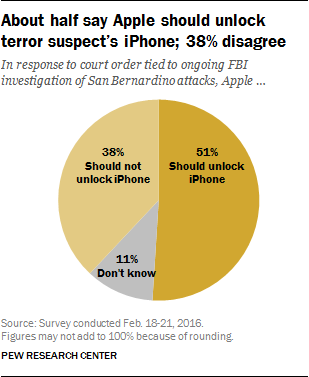What's the percentage of people who don't choose whether Apple should unlock the iPhone? According to the image which displays a chart from a survey, 11% of the respondents are undecided on whether Apple should unlock the iPhone. 